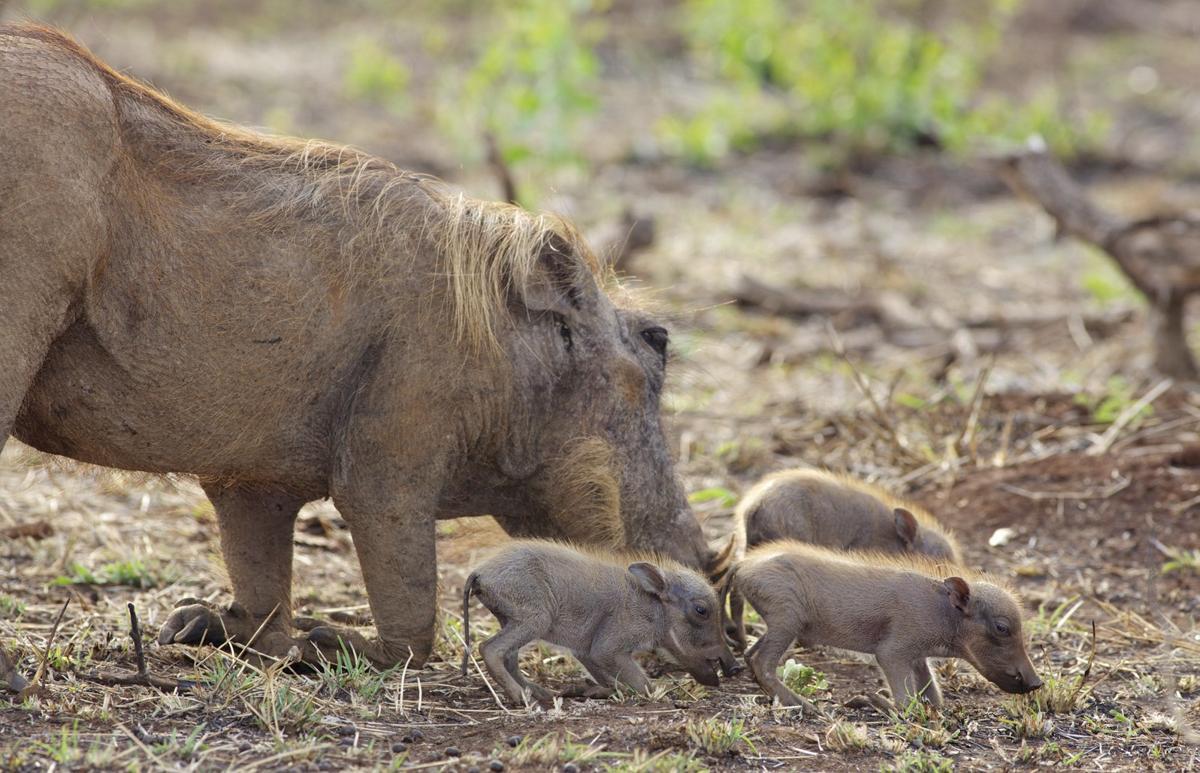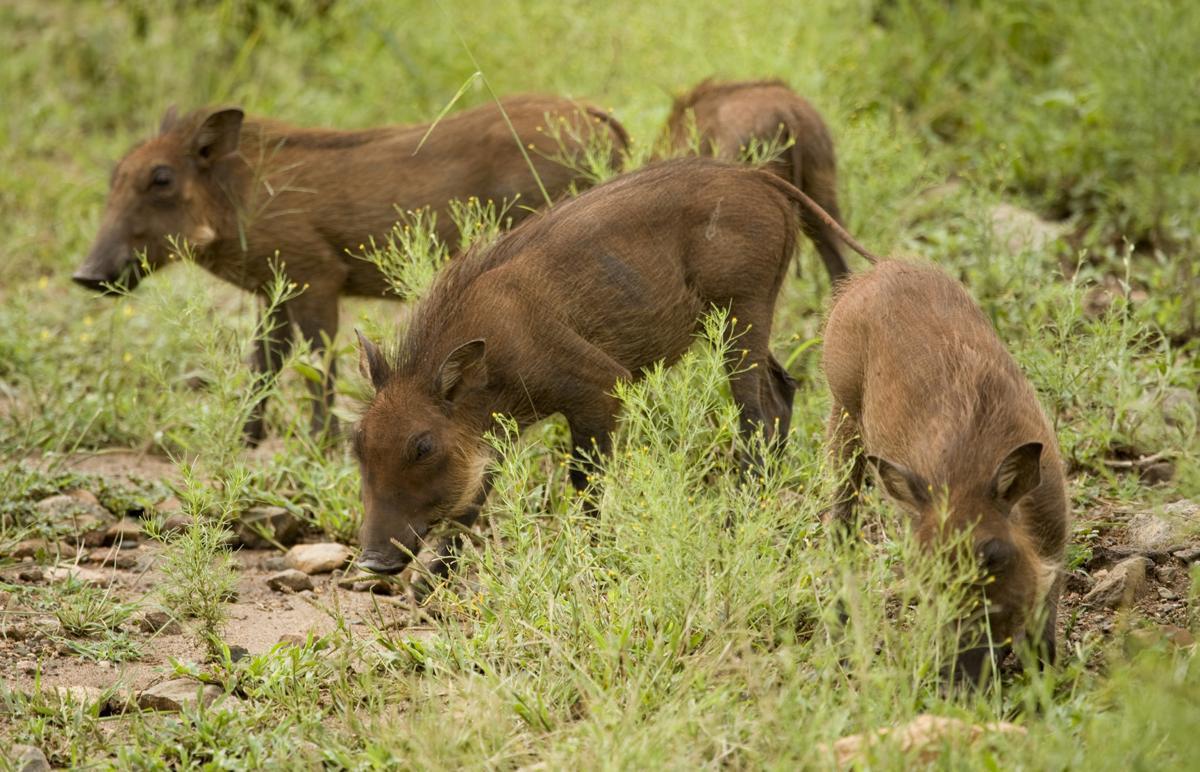The first image is the image on the left, the second image is the image on the right. Considering the images on both sides, is "The right image contains exactly five warthogs." valid? Answer yes or no. No. The first image is the image on the left, the second image is the image on the right. Given the left and right images, does the statement "An image shows at least four young warthogs and an adult moving along a wide dirt path flanked by grass." hold true? Answer yes or no. No. 